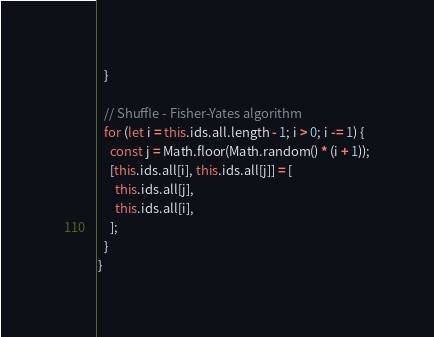<code> <loc_0><loc_0><loc_500><loc_500><_JavaScript_>  }

  // Shuffle - Fisher-Yates algorithm
  for (let i = this.ids.all.length - 1; i > 0; i -= 1) {
    const j = Math.floor(Math.random() * (i + 1));
    [this.ids.all[i], this.ids.all[j]] = [
      this.ids.all[j],
      this.ids.all[i],
    ];
  }
}
</code> 